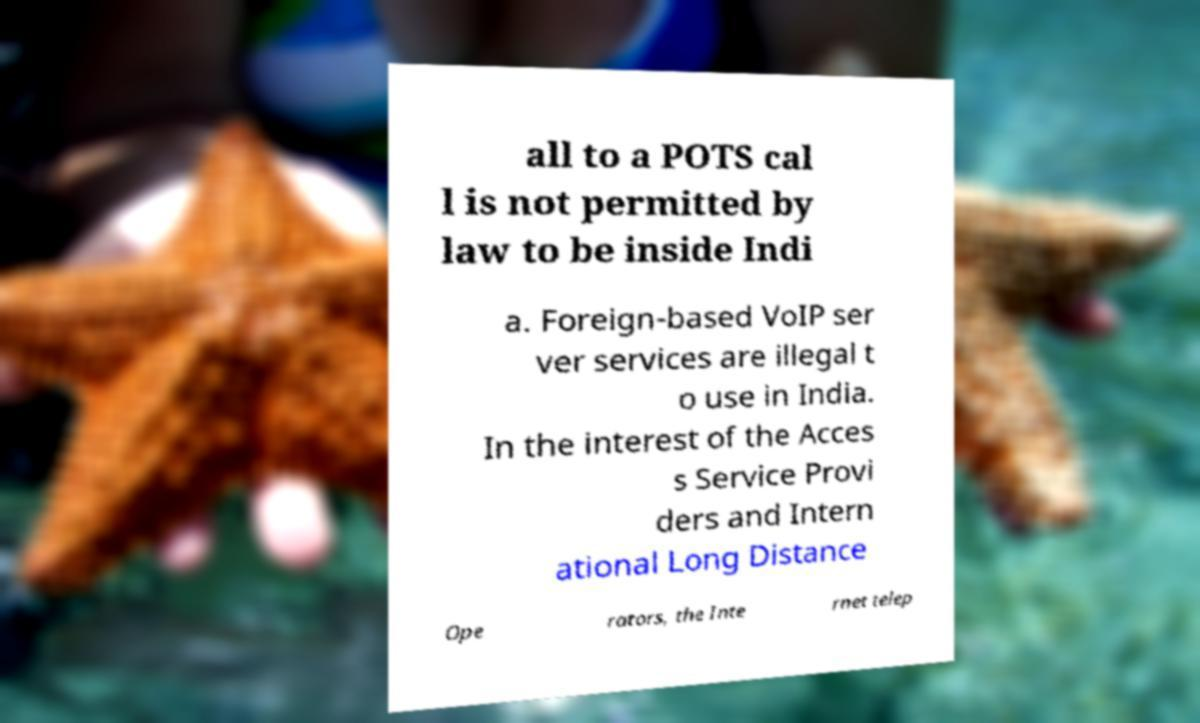Could you assist in decoding the text presented in this image and type it out clearly? all to a POTS cal l is not permitted by law to be inside Indi a. Foreign-based VoIP ser ver services are illegal t o use in India. In the interest of the Acces s Service Provi ders and Intern ational Long Distance Ope rators, the Inte rnet telep 